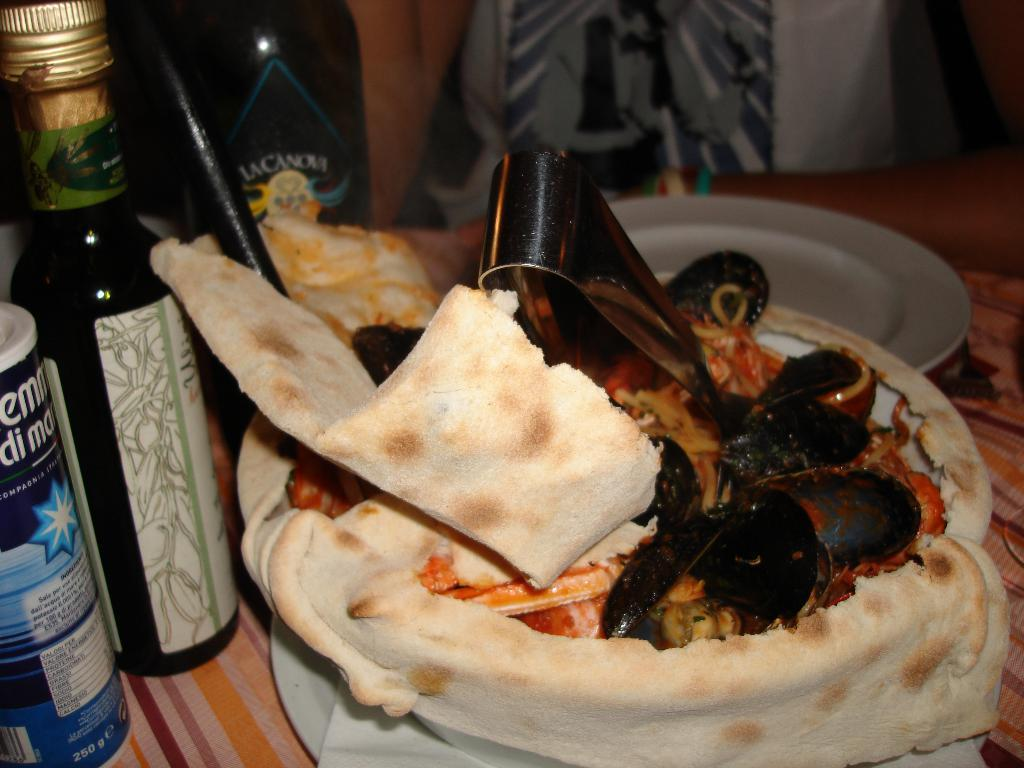What is in the bowl that is visible in the image? There is food in a bowl in the image. What can be seen on the left side of the image? There is a bottle on the left side of the image. What is covering the table in the image? The table in the image is covered with a cloth. What is visible in the background of the image? There is a curtain visible in the background of the image. What color is the stem of the winter vegetable in the image? There is no winter vegetable or stem present in the image. What type of color is the curtain in the image? The provided facts do not mention the color of the curtain, so it cannot be determined from the image. 